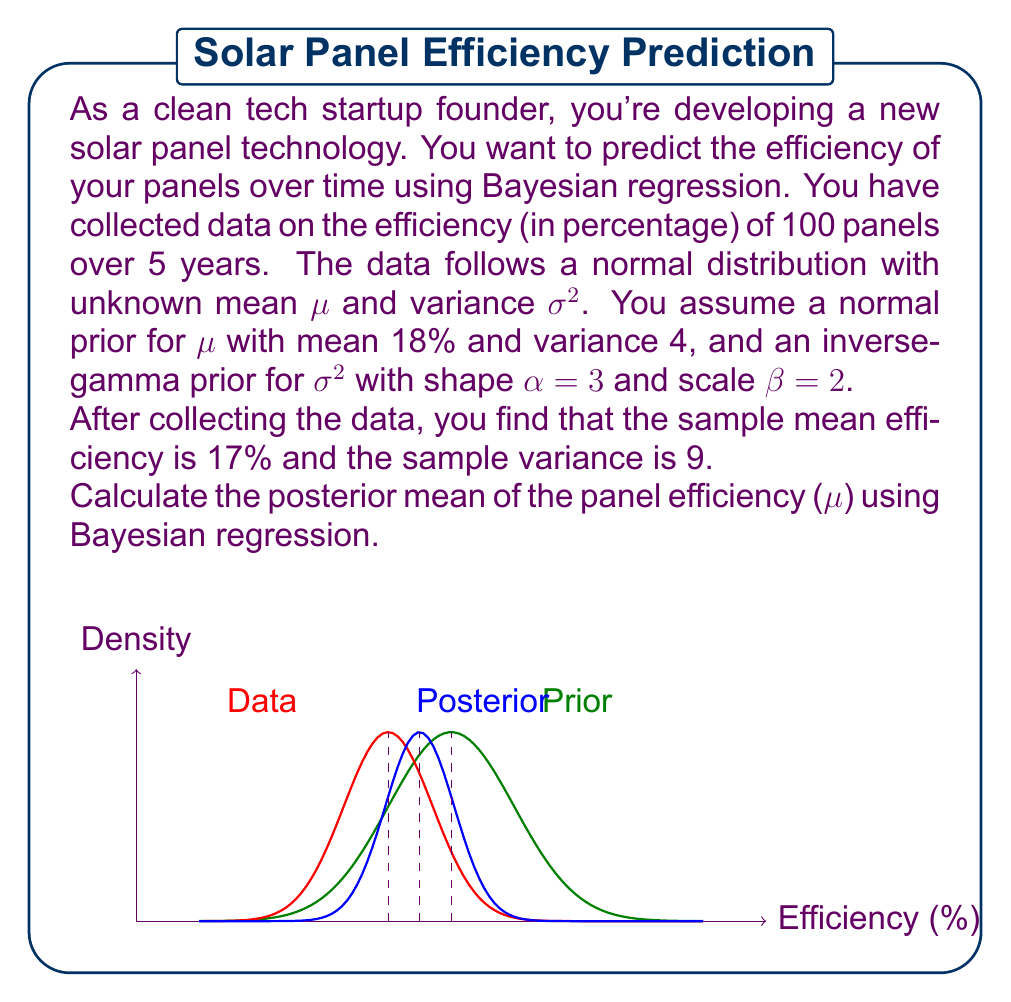Could you help me with this problem? Let's approach this step-by-step using Bayesian regression:

1) In Bayesian regression, we update our prior beliefs with observed data to obtain a posterior distribution.

2) Given:
   - Prior distribution of μ: $N(18, 4)$
   - Prior distribution of σ²: $IG(3, 2)$
   - Sample mean: $\bar{x} = 17$
   - Sample variance: $s^2 = 9$
   - Sample size: $n = 100$

3) The posterior distribution of μ given the data is also normal. We need to calculate its parameters.

4) The posterior mean is a weighted average of the prior mean and the sample mean:

   $$ \mu_{posterior} = \frac{\frac{\mu_{prior}}{\sigma_{prior}^2} + \frac{n\bar{x}}{\sigma^2}}{\frac{1}{\sigma_{prior}^2} + \frac{n}{\sigma^2}} $$

5) We don't know the true σ², but we can approximate it with the sample variance s²:

   $$ \mu_{posterior} \approx \frac{\frac{18}{4} + \frac{100 * 17}{9}}{\frac{1}{4} + \frac{100}{9}} $$

6) Simplifying:

   $$ \mu_{posterior} \approx \frac{4.5 + 188.89}{0.25 + 11.11} $$

   $$ \mu_{posterior} \approx \frac{193.39}{11.36} $$

   $$ \mu_{posterior} \approx 17.02 $$

Therefore, the posterior mean efficiency is approximately 17.02%.
Answer: 17.02% 